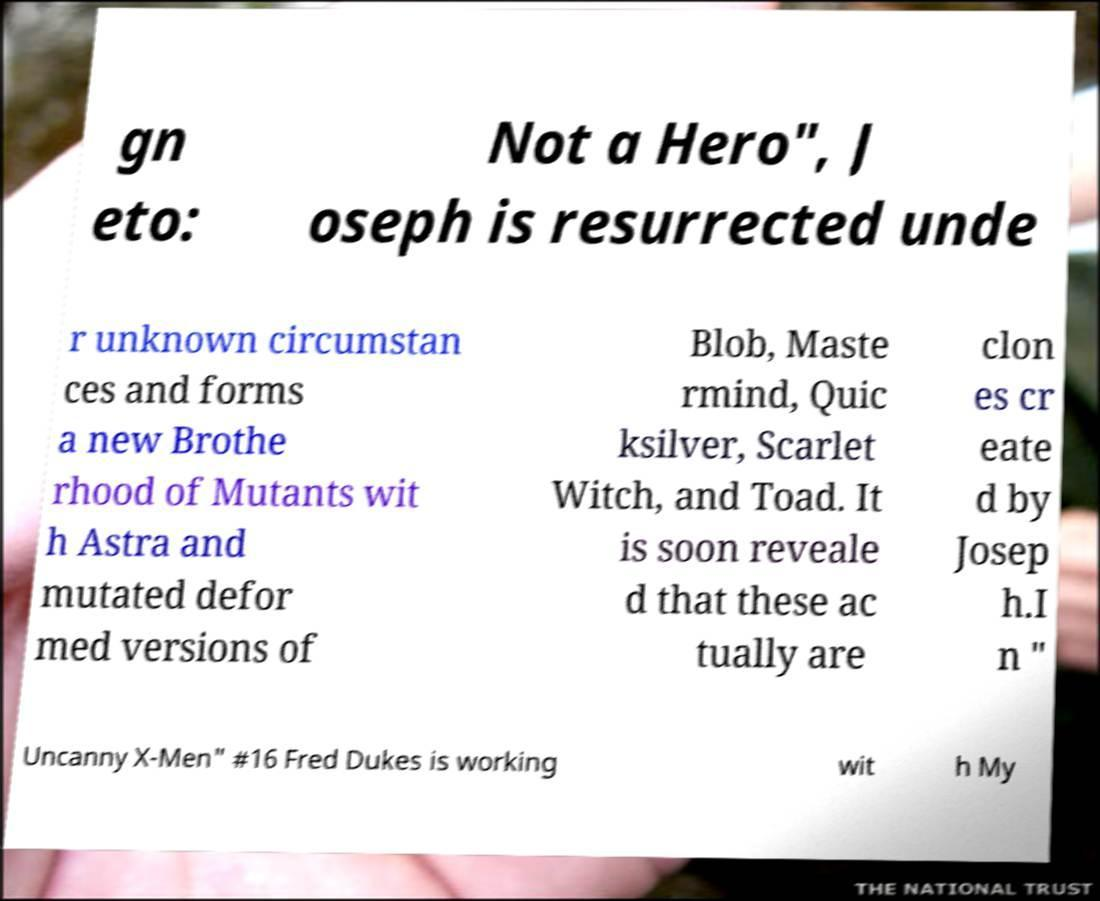Can you infer the context in which the 'Not a Hero' phrase is used? Based on the text surrounding 'Not a Hero,' it seems to refer to the character Joseph, who is resurrected under unknown circumstances. The phrase may imply a complex moral status or a turning point in Joseph's character portrayal, hinting that his actions or intentions post-resurrection may not be traditionally heroic, perhaps due to the creation of clones. 